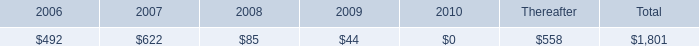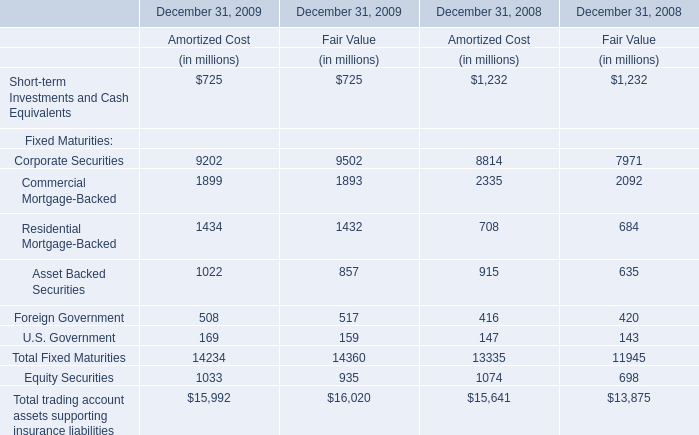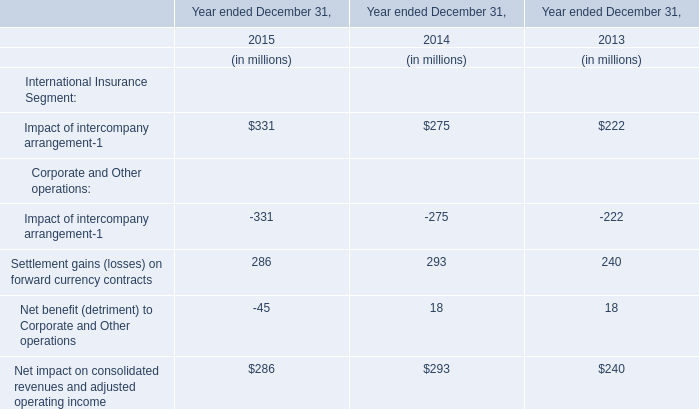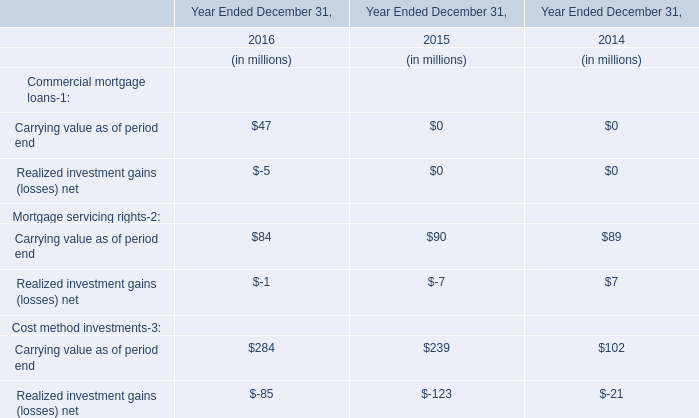in 2006 what was the ratio of the long-term debt payments due dealer remarketable securities to the medium-term notes 
Computations: (350 / 62)
Answer: 5.64516. 